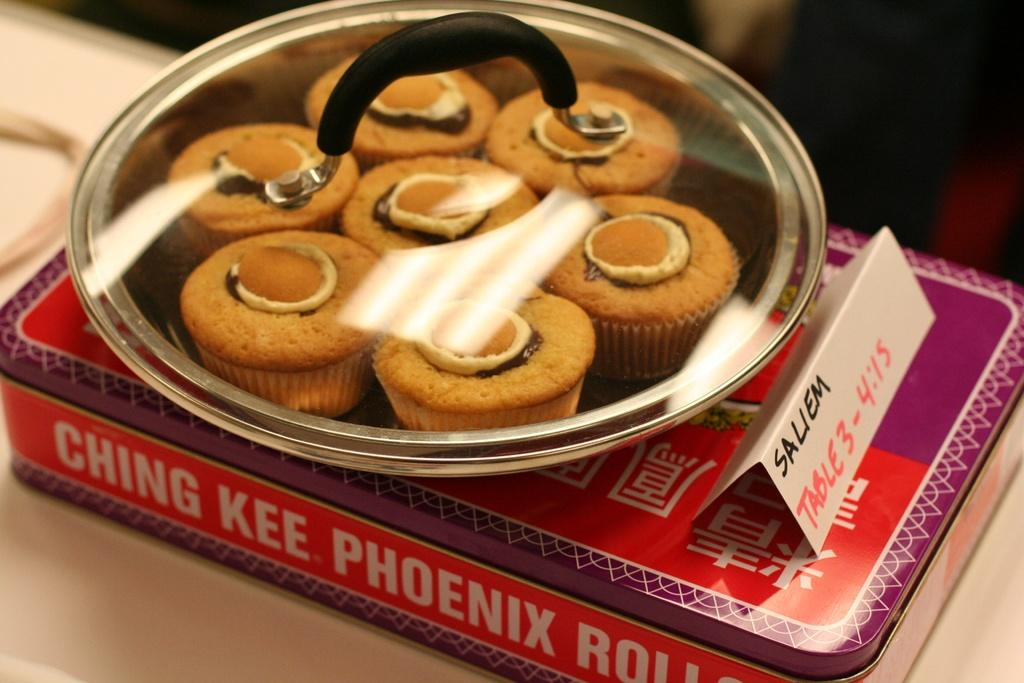What object is located in the image? There is a box in the image. What is the main subject in the middle of the image? There is a bowl in the middle of the image. What is inside the bowl? The bowl contains cupcakes. How many chickens are sitting on the cupcakes in the image? There are no chickens present in the image; the bowl contains cupcakes. Can you tell me how the zebra is helping with the cupcakes in the image? There is no zebra present in the image, so it cannot be helping with the cupcakes. 